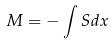Convert formula to latex. <formula><loc_0><loc_0><loc_500><loc_500>M = - \int S d x</formula> 